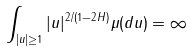Convert formula to latex. <formula><loc_0><loc_0><loc_500><loc_500>\int _ { | u | \geq 1 } | u | ^ { 2 / ( 1 - 2 H ) } \mu ( d u ) = \infty</formula> 